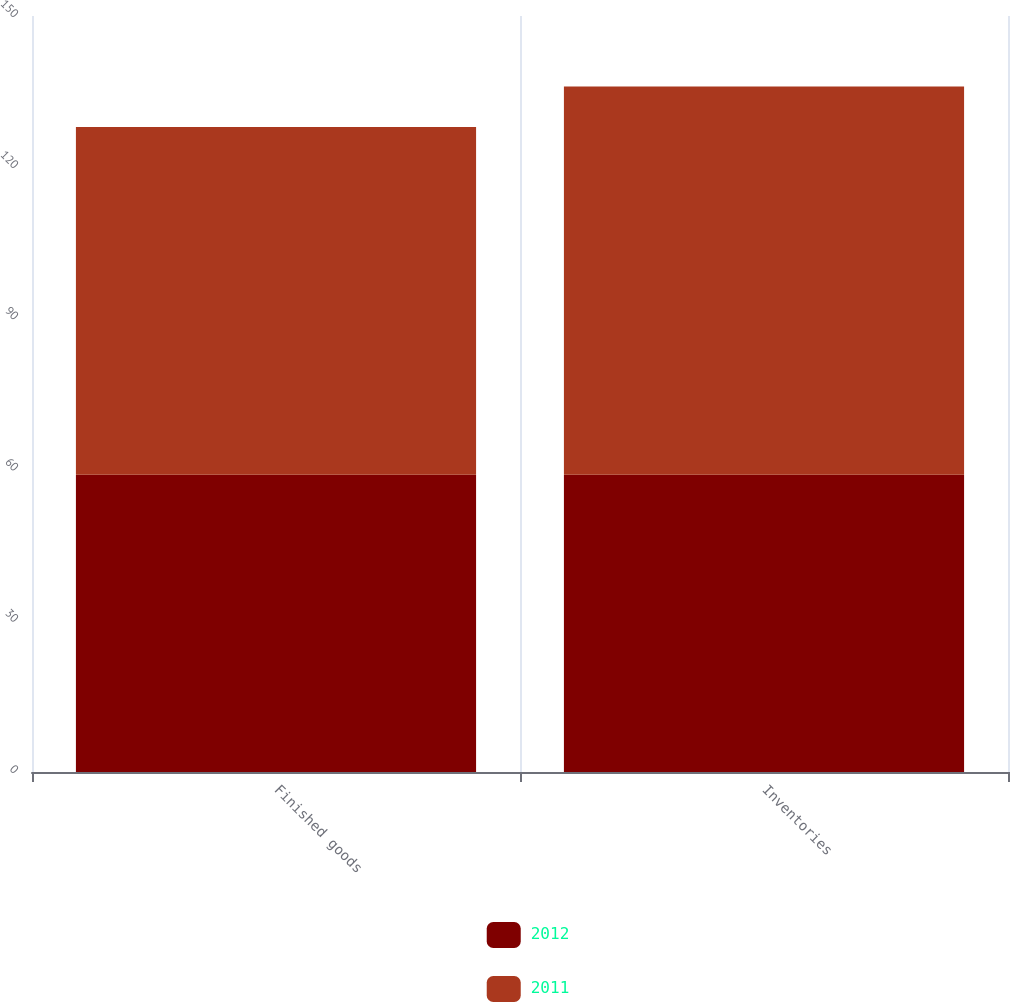Convert chart to OTSL. <chart><loc_0><loc_0><loc_500><loc_500><stacked_bar_chart><ecel><fcel>Finished goods<fcel>Inventories<nl><fcel>2012<fcel>59<fcel>59<nl><fcel>2011<fcel>69<fcel>77<nl></chart> 